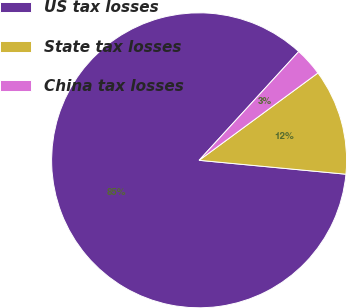<chart> <loc_0><loc_0><loc_500><loc_500><pie_chart><fcel>US tax losses<fcel>State tax losses<fcel>China tax losses<nl><fcel>85.3%<fcel>11.59%<fcel>3.11%<nl></chart> 